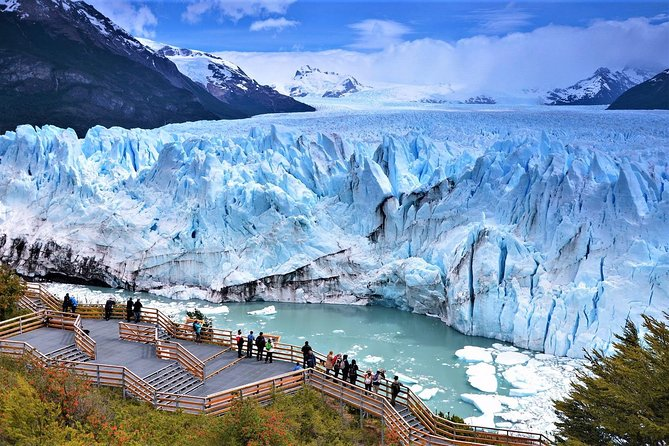What impact do tourists have on this area? Tourists have both positive and negative impacts on the Perito Moreno Glacier area. Economically, tourism supports local jobs and contributes to regional income, helping to fund conservation efforts. However, the presence of tourists also poses challenges such as waste management and potential disturbance to the local ecosystem. Managing these impacts requires careful planning and sustainable practices to ensure that this natural wonder is preserved for future generations. 